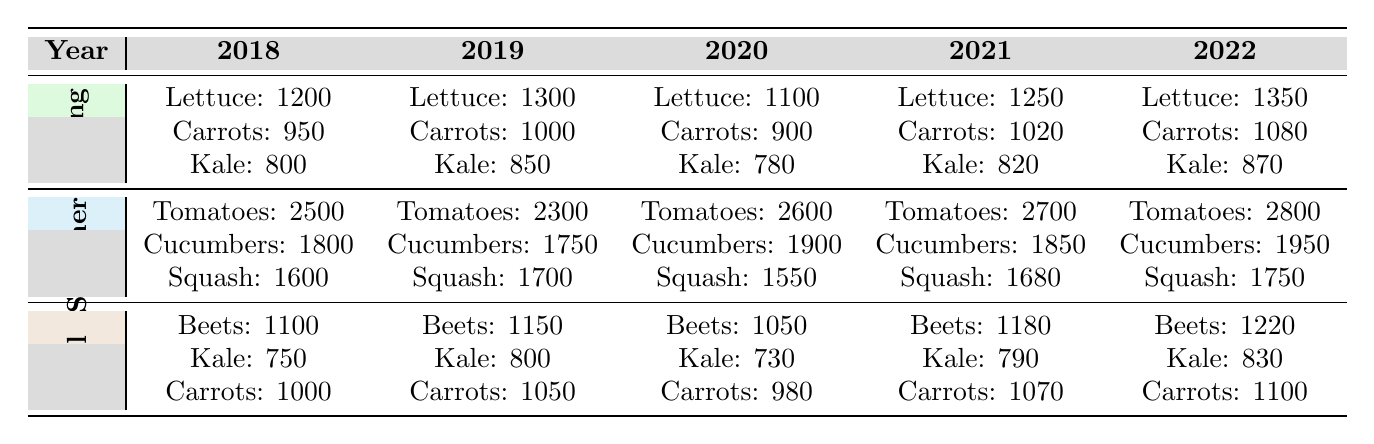What was the highest yield for Tomatoes over the years? By looking at the summer yields for Tomatoes, the values are: 2500 in 2018, 2300 in 2019, 2600 in 2020, 2700 in 2021, and 2800 in 2022. The highest value is 2800 in 2022.
Answer: 2800 Which year had the lowest yield for Kale in the Spring? The Spring yields for Kale are: 800 in 2018, 850 in 2019, 780 in 2020, 820 in 2021, and 870 in 2022. The lowest yield is 780 in 2020.
Answer: 2020 How much did the yield of Cucumbers increase from 2019 to 2022? The yield of Cucumbers was 1750 in 2019 and 1950 in 2022. The increase is 1950 - 1750 = 200.
Answer: 200 What was the total yield of Beets from 2018 to 2022? The yields for Beets are: 1100 (2018) + 1150 (2019) + 1050 (2020) + 1180 (2021) + 1220 (2022) = 1100 + 1150 + 1050 + 1180 + 1220 = 5750.
Answer: 5750 Did the yield of Carrots in Fall ever exceed 1100 across the years? The Fall yields for Carrots are: 1000 (2018), 1050 (2019), 980 (2020), 1070 (2021), and 1100 (2022). The maximum is 1100, so yes, it did exceed that value in 2022.
Answer: Yes What was the average yield of Lettuce from Spring over the 5 years? The Spring yields of Lettuce are: 1200 in 2018, 1300 in 2019, 1100 in 2020, 1250 in 2021, and 1350 in 2022. The average is (1200 + 1300 + 1100 + 1250 + 1350) / 5 = 1240.
Answer: 1240 Which crop had the highest consistent yield in Summer across all five years? Checking the Summer yields, Tomatoes: 2500, 2300, 2600, 2700, 2800; Cucumbers: 1800, 1750, 1900, 1850, 1950; Squash: 1600, 1700, 1550, 1680, 1750. Tomatoes consistently had the highest yield across all years.
Answer: Tomatoes What increase in yield is seen in Kale from Spring 2018 to Spring 2022? The yields for Kale in Spring were: 800 (2018) and 870 (2022). The increase is 870 - 800 = 70.
Answer: 70 In what year did Cucumbers have the highest yield in Summer? The Summer yields for Cucumbers were: 1800 (2018), 1750 (2019), 1900 (2020), 1850 (2021), and 1950 (2022). The highest yield of 1950 occurred in 2022.
Answer: 2022 Which season produced the most yield for Squash in 2021? The Squash yields are: Summer 1680, Spring data is unavailable, Fall data is unavailable. Summer yielded 1680 in 2021 as it's the only available season data for that year.
Answer: Summer 1680 